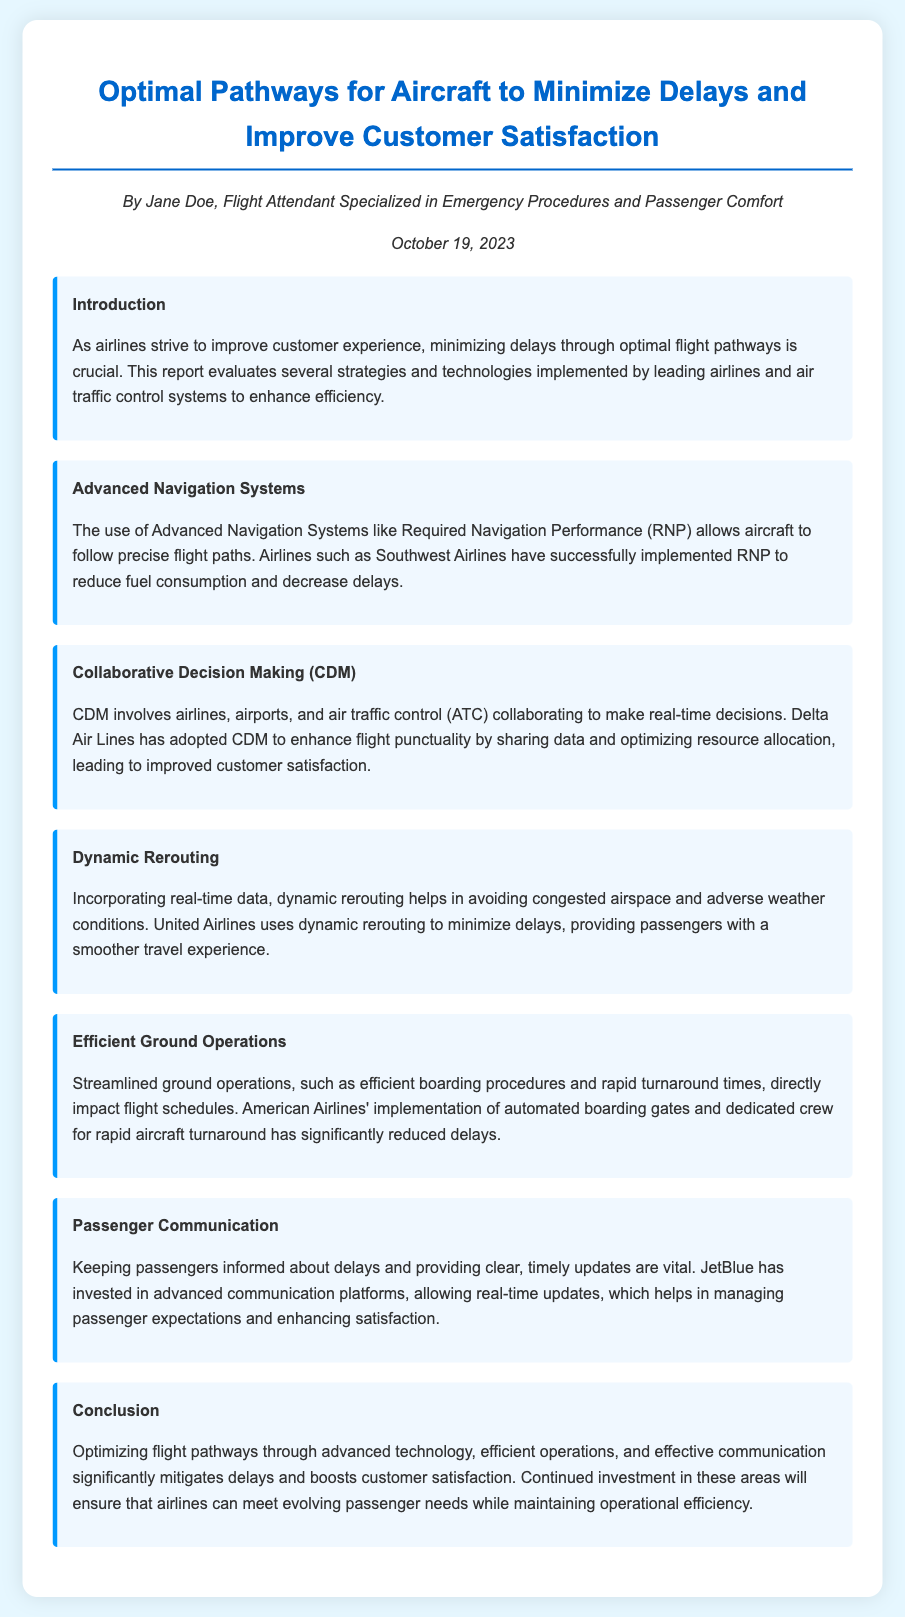what is the title of the report? The title of the report is stated at the top of the document.
Answer: Optimal Pathways for Aircraft to Minimize Delays and Improve Customer Satisfaction who is the author of the report? The author’s name is provided in the document’s author-date section.
Answer: Jane Doe what is the implementation date of the report? The date the report was published is mentioned in the author-date section.
Answer: October 19, 2023 which airline successfully implemented Required Navigation Performance? The report references the application of RNP by a specific airline.
Answer: Southwest Airlines what strategy does Delta Air Lines use to enhance flight punctuality? The document describes Delta’s approach to improving punctuality.
Answer: Collaborative Decision Making (CDM) how does United Airlines minimize delays? The report explains the method United Airlines employs to avoid delays.
Answer: Dynamic rerouting what technology does JetBlue invest in for passenger updates? The type of platform JetBlue uses for communication is mentioned in the Passenger Communication section.
Answer: Advanced communication platforms what is a major benefit of streamlined ground operations? The advantages of improved ground operations in the document highlight their effect on schedules.
Answer: Reduced delays how does American Airlines achieve rapid aircraft turnaround? American Airlines' method for speedy operations is detailed in the Efficient Ground Operations section.
Answer: Automated boarding gates and dedicated crew 